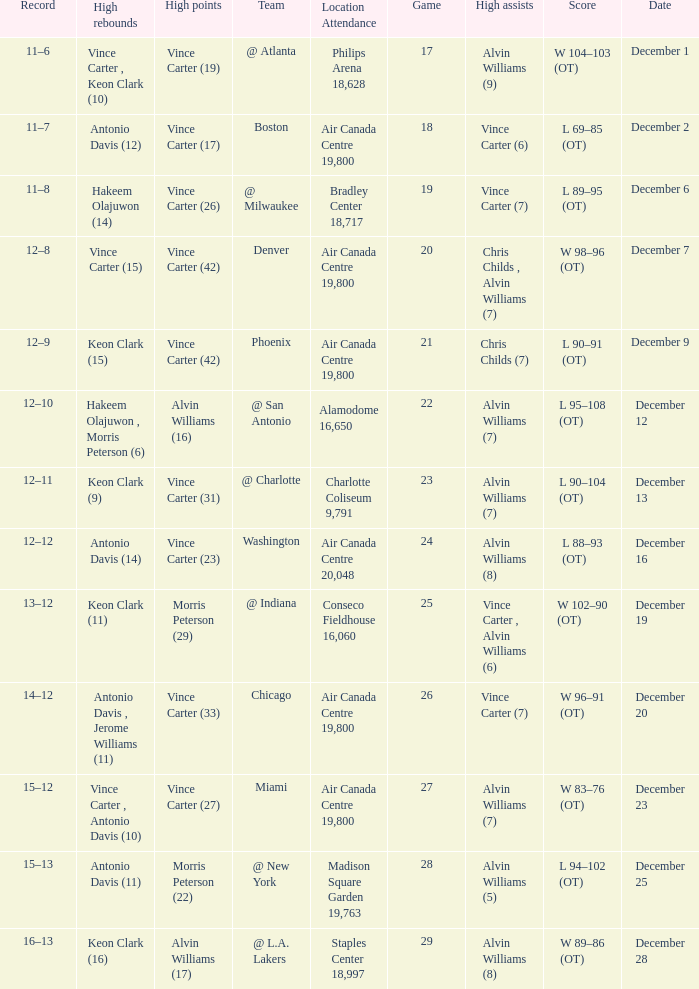Who scored the most points against Washington? Vince Carter (23). 